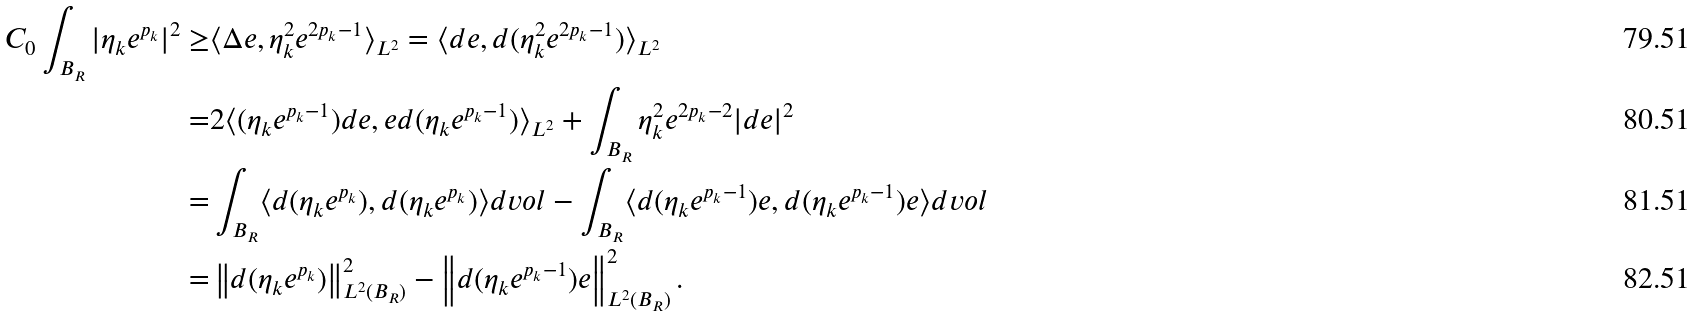<formula> <loc_0><loc_0><loc_500><loc_500>C _ { 0 } \int _ { B _ { R } } | \eta _ { k } e ^ { p _ { k } } | ^ { 2 } \geq & \langle \Delta e , \eta _ { k } ^ { 2 } e ^ { 2 p _ { k } - 1 } \rangle _ { L ^ { 2 } } = \langle d e , d ( \eta _ { k } ^ { 2 } e ^ { 2 p _ { k } - 1 } ) \rangle _ { L ^ { 2 } } \\ = & 2 \langle ( \eta _ { k } e ^ { p _ { k } - 1 } ) d e , e d ( \eta _ { k } e ^ { p _ { k } - 1 } ) \rangle _ { L ^ { 2 } } + \int _ { B _ { R } } \eta _ { k } ^ { 2 } e ^ { 2 p _ { k } - 2 } | d e | ^ { 2 } \\ = & \int _ { B _ { R } } \langle d ( \eta _ { k } e ^ { p _ { k } } ) , d ( \eta _ { k } e ^ { p _ { k } } ) \rangle d v o l - \int _ { B _ { R } } \langle d ( \eta _ { k } e ^ { p _ { k } - 1 } ) e , d ( \eta _ { k } e ^ { p _ { k } - 1 } ) e \rangle d v o l \\ = & \left \| d ( \eta _ { k } e ^ { p _ { k } } ) \right \| ^ { 2 } _ { L ^ { 2 } ( B _ { R } ) } - \left \| d ( \eta _ { k } e ^ { p _ { k } - 1 } ) e \right \| _ { L ^ { 2 } ( B _ { R } ) } ^ { 2 } .</formula> 